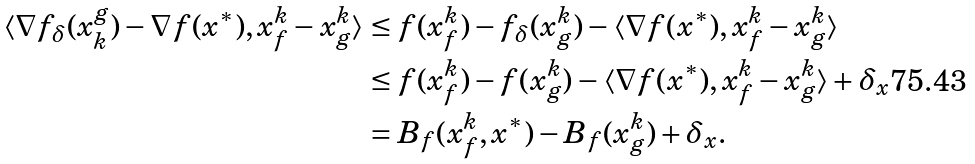Convert formula to latex. <formula><loc_0><loc_0><loc_500><loc_500>\langle \nabla f _ { \delta } ( x ^ { g } _ { k } ) - \nabla f ( x ^ { * } ) , x _ { f } ^ { k } - x _ { g } ^ { k } \rangle & \leq f ( x _ { f } ^ { k } ) - f _ { \delta } ( x _ { g } ^ { k } ) - \langle \nabla f ( x ^ { * } ) , x _ { f } ^ { k } - x _ { g } ^ { k } \rangle \\ & \leq f ( x _ { f } ^ { k } ) - f ( x _ { g } ^ { k } ) - \langle \nabla f ( x ^ { * } ) , x _ { f } ^ { k } - x _ { g } ^ { k } \rangle + \delta _ { x } \\ & = B _ { f } ( x _ { f } ^ { k } , x ^ { * } ) - B _ { f } ( x _ { g } ^ { k } ) + \delta _ { x } .</formula> 